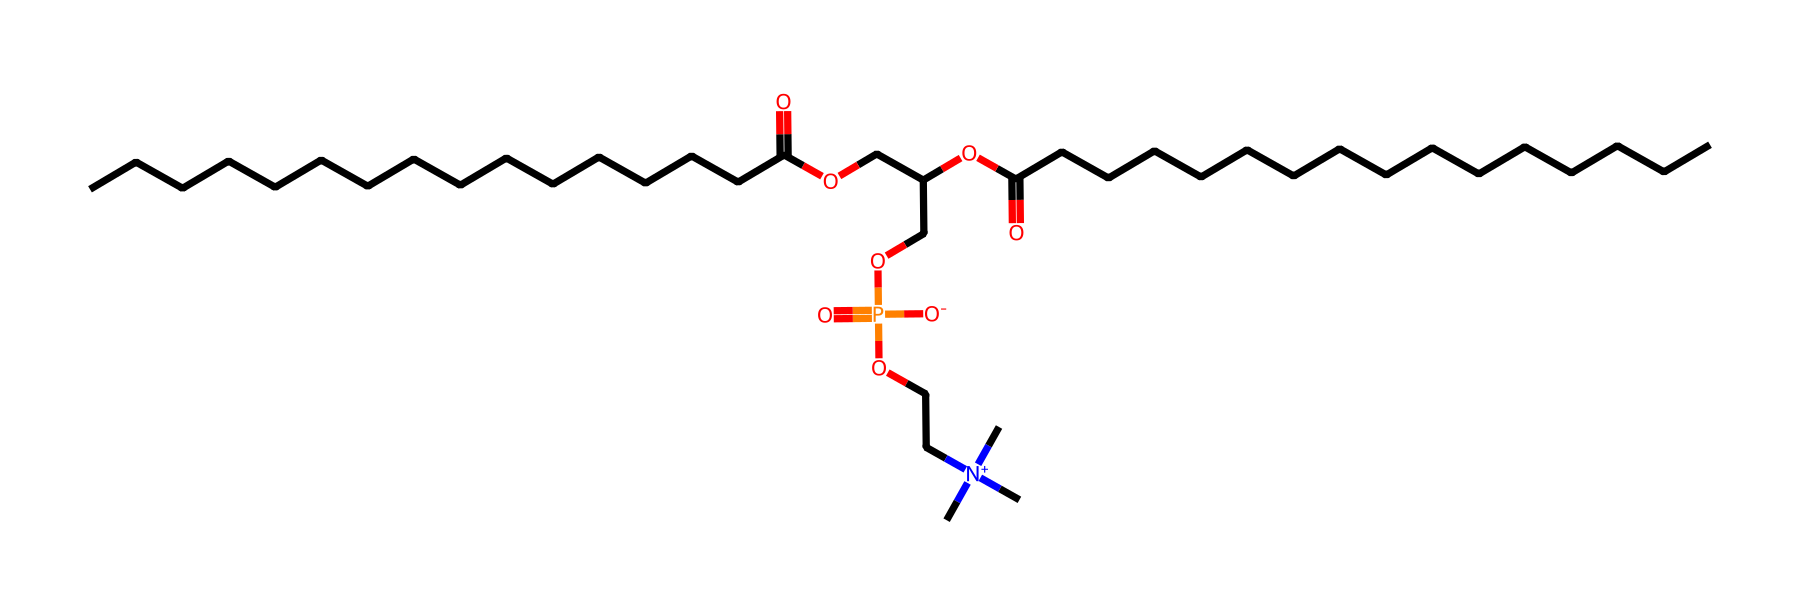How many carbon atoms are in this structure? Count the number of "C" letters in the SMILES representation. This structure shows an arrangement indicating a total of 23 carbon atoms.
Answer: 23 What type of functional groups are present in this molecule? By analyzing the SMILES, we can identify functional groups such as esters (due to the presence of "O=C-O" and "OC") and phosphate (noted by "P(=O)").
Answer: ester and phosphate What is the overall charge of this molecule? The molecule includes a "N+" which indicates a positively charged nitrogen due to the quaternary amine structure. The presence of anionic groups like "[O-]" provides balance. Therefore, overall, the charge can be considered neutral with a prevalent positive charge.
Answer: neutral to positive Which part of the molecule contributes to its surfactant properties? The hydrophobic (water-repelling) alkyl chains (CCCCCCCCCCCCCCCC and CCCCCCCCCCCCCCCC) and the hydrophilic (water-attracting) phosphate group play critical roles in surfactant behavior. This arrangement allows it to reduce surface tension.
Answer: alkyl chains and phosphate group How many ester linkages are present in this molecule? The presence of ester linkages can be identified by the arrangement of carbon and oxygen atoms featuring C(=O)O. In the SMILES, there are two distinct locations where this occurs.
Answer: 2 Does this molecule have a polar or nonpolar character? Due to the presence of a phosphate group and the overall structure of oriented hydrophilic and hydrophobic zones, the molecule exhibits amphiphilic character (having both polar and nonpolar parts) but can be leaned towards polar due to the phosphate functional group.
Answer: amphiphilic 